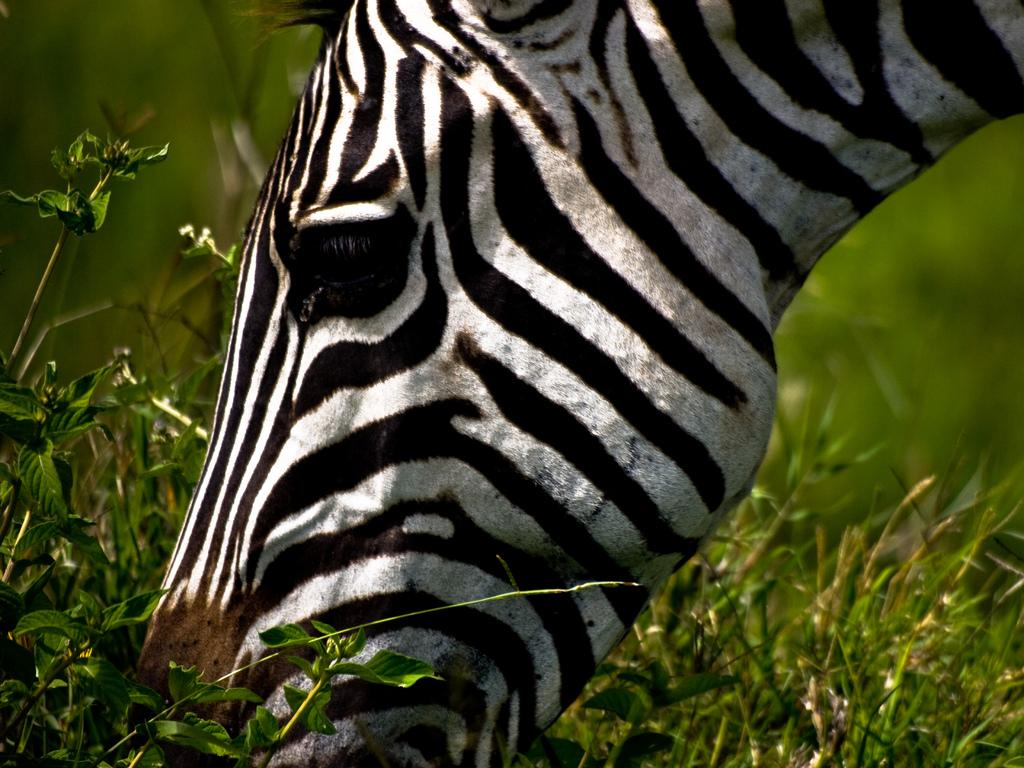What animal is present in the image? There is a zebra in the image. What is the zebra doing in the image? The zebra is grazing on the ground. What type of vegetation can be seen in the image? There are small plants and grass in the image. Can you describe the background of the image? The background of the image is blurry. What type of disease is affecting the dolls in the image? There are no dolls present in the image, and therefore no disease affecting them can be observed. 